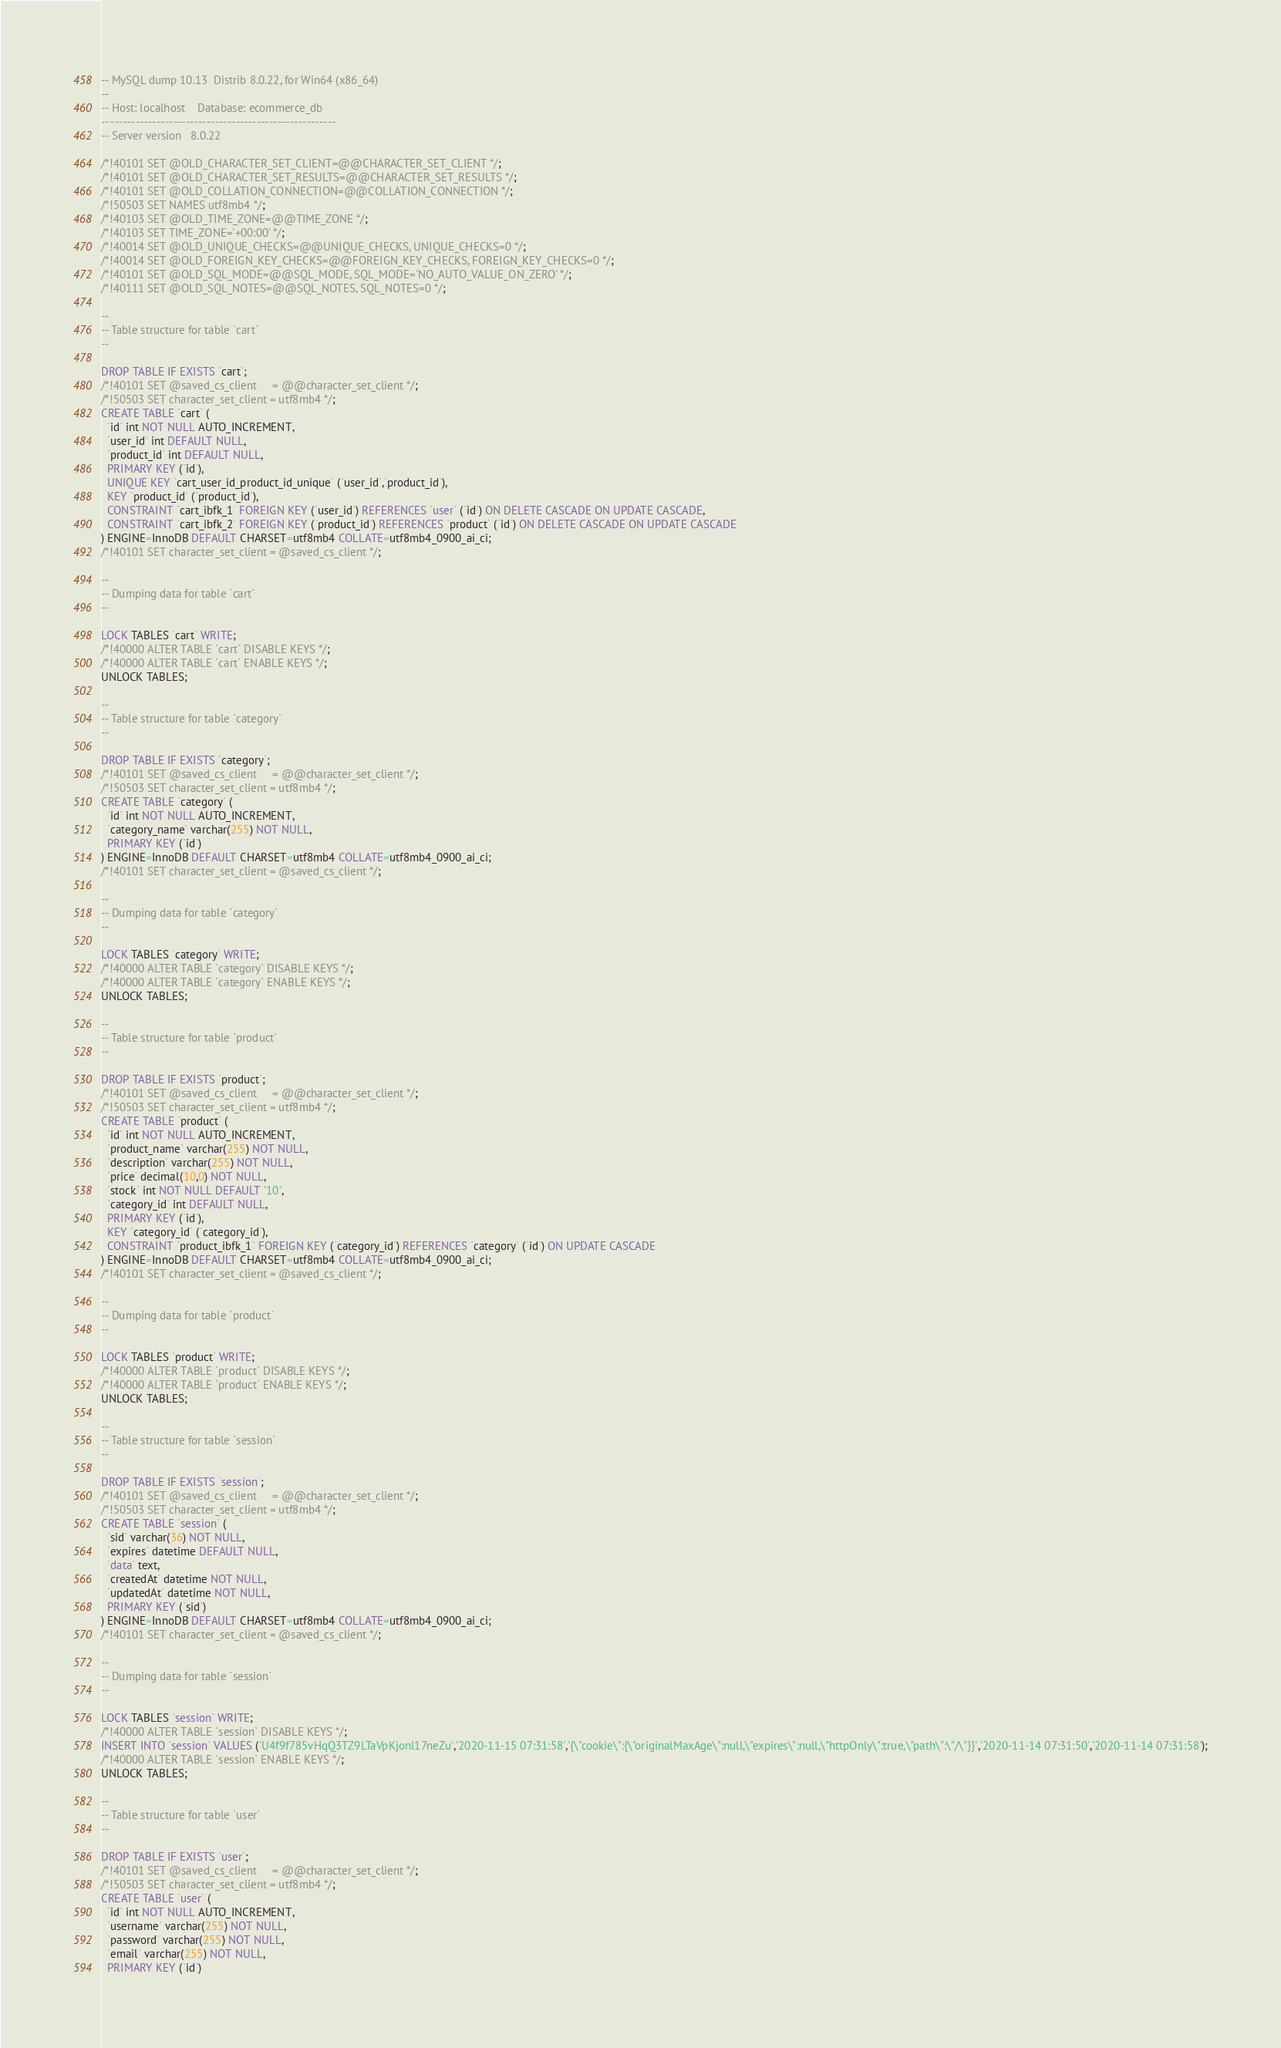Convert code to text. <code><loc_0><loc_0><loc_500><loc_500><_SQL_>-- MySQL dump 10.13  Distrib 8.0.22, for Win64 (x86_64)
--
-- Host: localhost    Database: ecommerce_db
-- ------------------------------------------------------
-- Server version	8.0.22

/*!40101 SET @OLD_CHARACTER_SET_CLIENT=@@CHARACTER_SET_CLIENT */;
/*!40101 SET @OLD_CHARACTER_SET_RESULTS=@@CHARACTER_SET_RESULTS */;
/*!40101 SET @OLD_COLLATION_CONNECTION=@@COLLATION_CONNECTION */;
/*!50503 SET NAMES utf8mb4 */;
/*!40103 SET @OLD_TIME_ZONE=@@TIME_ZONE */;
/*!40103 SET TIME_ZONE='+00:00' */;
/*!40014 SET @OLD_UNIQUE_CHECKS=@@UNIQUE_CHECKS, UNIQUE_CHECKS=0 */;
/*!40014 SET @OLD_FOREIGN_KEY_CHECKS=@@FOREIGN_KEY_CHECKS, FOREIGN_KEY_CHECKS=0 */;
/*!40101 SET @OLD_SQL_MODE=@@SQL_MODE, SQL_MODE='NO_AUTO_VALUE_ON_ZERO' */;
/*!40111 SET @OLD_SQL_NOTES=@@SQL_NOTES, SQL_NOTES=0 */;

--
-- Table structure for table `cart`
--

DROP TABLE IF EXISTS `cart`;
/*!40101 SET @saved_cs_client     = @@character_set_client */;
/*!50503 SET character_set_client = utf8mb4 */;
CREATE TABLE `cart` (
  `id` int NOT NULL AUTO_INCREMENT,
  `user_id` int DEFAULT NULL,
  `product_id` int DEFAULT NULL,
  PRIMARY KEY (`id`),
  UNIQUE KEY `cart_user_id_product_id_unique` (`user_id`,`product_id`),
  KEY `product_id` (`product_id`),
  CONSTRAINT `cart_ibfk_1` FOREIGN KEY (`user_id`) REFERENCES `user` (`id`) ON DELETE CASCADE ON UPDATE CASCADE,
  CONSTRAINT `cart_ibfk_2` FOREIGN KEY (`product_id`) REFERENCES `product` (`id`) ON DELETE CASCADE ON UPDATE CASCADE
) ENGINE=InnoDB DEFAULT CHARSET=utf8mb4 COLLATE=utf8mb4_0900_ai_ci;
/*!40101 SET character_set_client = @saved_cs_client */;

--
-- Dumping data for table `cart`
--

LOCK TABLES `cart` WRITE;
/*!40000 ALTER TABLE `cart` DISABLE KEYS */;
/*!40000 ALTER TABLE `cart` ENABLE KEYS */;
UNLOCK TABLES;

--
-- Table structure for table `category`
--

DROP TABLE IF EXISTS `category`;
/*!40101 SET @saved_cs_client     = @@character_set_client */;
/*!50503 SET character_set_client = utf8mb4 */;
CREATE TABLE `category` (
  `id` int NOT NULL AUTO_INCREMENT,
  `category_name` varchar(255) NOT NULL,
  PRIMARY KEY (`id`)
) ENGINE=InnoDB DEFAULT CHARSET=utf8mb4 COLLATE=utf8mb4_0900_ai_ci;
/*!40101 SET character_set_client = @saved_cs_client */;

--
-- Dumping data for table `category`
--

LOCK TABLES `category` WRITE;
/*!40000 ALTER TABLE `category` DISABLE KEYS */;
/*!40000 ALTER TABLE `category` ENABLE KEYS */;
UNLOCK TABLES;

--
-- Table structure for table `product`
--

DROP TABLE IF EXISTS `product`;
/*!40101 SET @saved_cs_client     = @@character_set_client */;
/*!50503 SET character_set_client = utf8mb4 */;
CREATE TABLE `product` (
  `id` int NOT NULL AUTO_INCREMENT,
  `product_name` varchar(255) NOT NULL,
  `description` varchar(255) NOT NULL,
  `price` decimal(10,0) NOT NULL,
  `stock` int NOT NULL DEFAULT '10',
  `category_id` int DEFAULT NULL,
  PRIMARY KEY (`id`),
  KEY `category_id` (`category_id`),
  CONSTRAINT `product_ibfk_1` FOREIGN KEY (`category_id`) REFERENCES `category` (`id`) ON UPDATE CASCADE
) ENGINE=InnoDB DEFAULT CHARSET=utf8mb4 COLLATE=utf8mb4_0900_ai_ci;
/*!40101 SET character_set_client = @saved_cs_client */;

--
-- Dumping data for table `product`
--

LOCK TABLES `product` WRITE;
/*!40000 ALTER TABLE `product` DISABLE KEYS */;
/*!40000 ALTER TABLE `product` ENABLE KEYS */;
UNLOCK TABLES;

--
-- Table structure for table `session`
--

DROP TABLE IF EXISTS `session`;
/*!40101 SET @saved_cs_client     = @@character_set_client */;
/*!50503 SET character_set_client = utf8mb4 */;
CREATE TABLE `session` (
  `sid` varchar(36) NOT NULL,
  `expires` datetime DEFAULT NULL,
  `data` text,
  `createdAt` datetime NOT NULL,
  `updatedAt` datetime NOT NULL,
  PRIMARY KEY (`sid`)
) ENGINE=InnoDB DEFAULT CHARSET=utf8mb4 COLLATE=utf8mb4_0900_ai_ci;
/*!40101 SET character_set_client = @saved_cs_client */;

--
-- Dumping data for table `session`
--

LOCK TABLES `session` WRITE;
/*!40000 ALTER TABLE `session` DISABLE KEYS */;
INSERT INTO `session` VALUES ('U4f9f785vHqQ3TZ9LTaVpKjonl17neZu','2020-11-15 07:31:58','{\"cookie\":{\"originalMaxAge\":null,\"expires\":null,\"httpOnly\":true,\"path\":\"/\"}}','2020-11-14 07:31:50','2020-11-14 07:31:58');
/*!40000 ALTER TABLE `session` ENABLE KEYS */;
UNLOCK TABLES;

--
-- Table structure for table `user`
--

DROP TABLE IF EXISTS `user`;
/*!40101 SET @saved_cs_client     = @@character_set_client */;
/*!50503 SET character_set_client = utf8mb4 */;
CREATE TABLE `user` (
  `id` int NOT NULL AUTO_INCREMENT,
  `username` varchar(255) NOT NULL,
  `password` varchar(255) NOT NULL,
  `email` varchar(255) NOT NULL,
  PRIMARY KEY (`id`)</code> 